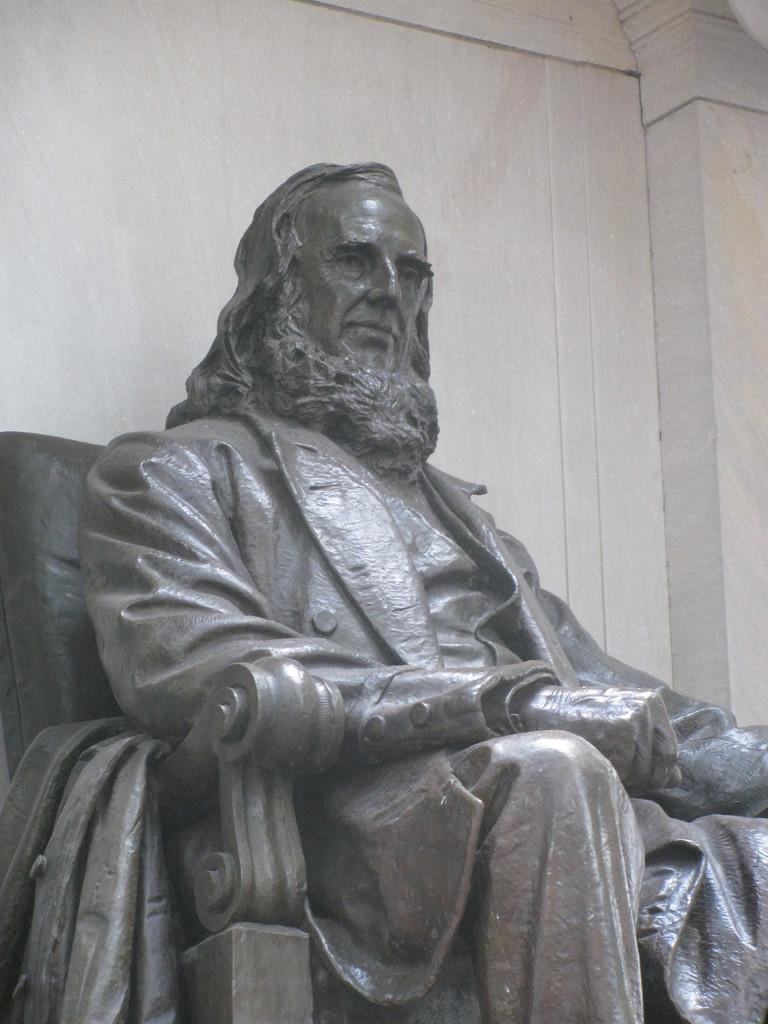In one or two sentences, can you explain what this image depicts? In this picture we can see a statue and a wall. 